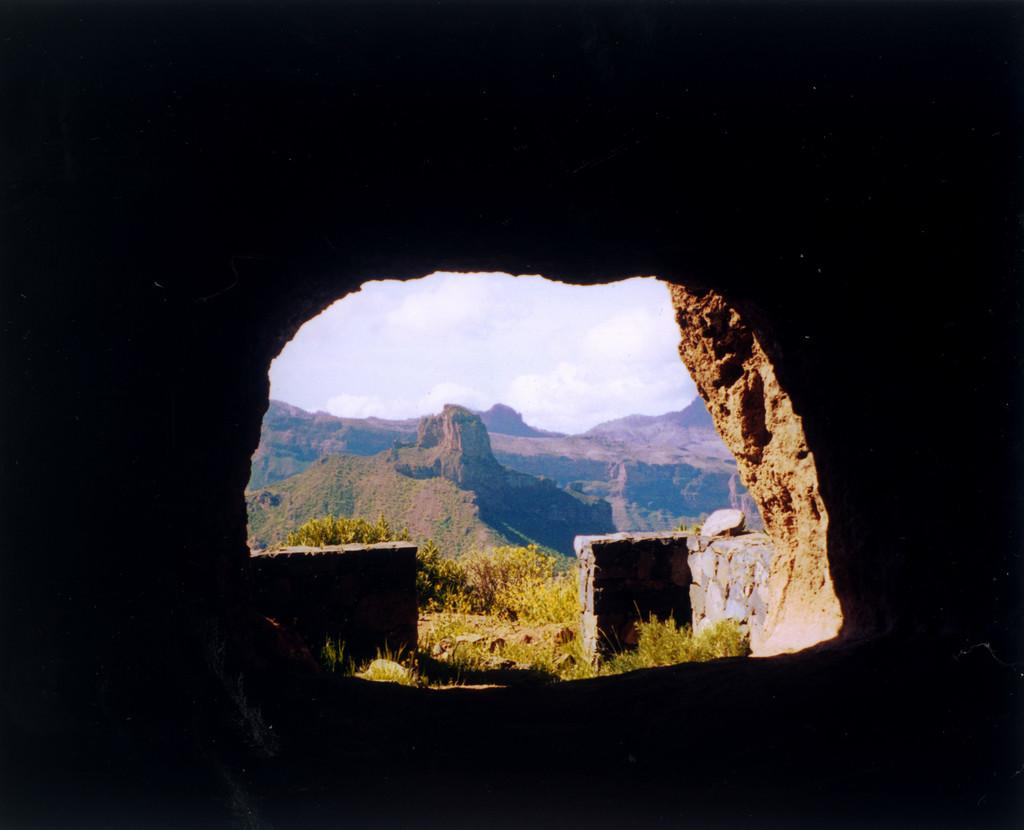What type of natural formation can be seen in the image? There is a cave made of rock in the image. What other geographical features are visible in the image? Mountains are visible in the image. What type of vegetation is present in the image? Plants and grass are visible in the image. What is visible at the top of the image? The sky is visible at the top of the image. What type of pie is being served in the cave in the image? There is no pie present in the image; it features a cave made of rock, mountains, plants, grass, and the sky. 